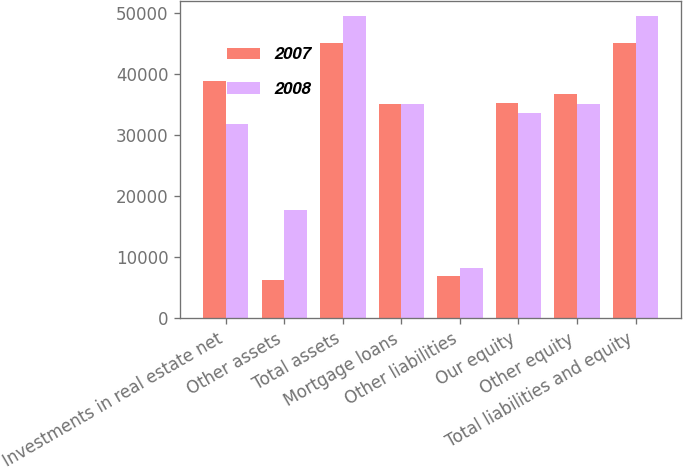Convert chart. <chart><loc_0><loc_0><loc_500><loc_500><stacked_bar_chart><ecel><fcel>Investments in real estate net<fcel>Other assets<fcel>Total assets<fcel>Mortgage loans<fcel>Other liabilities<fcel>Our equity<fcel>Other equity<fcel>Total liabilities and equity<nl><fcel>2007<fcel>38824<fcel>6199<fcel>45023<fcel>35140.5<fcel>6947<fcel>35275<fcel>36649<fcel>45023<nl><fcel>2008<fcel>31852<fcel>17680<fcel>49532<fcel>35140.5<fcel>8172<fcel>33634<fcel>35006<fcel>49532<nl></chart> 